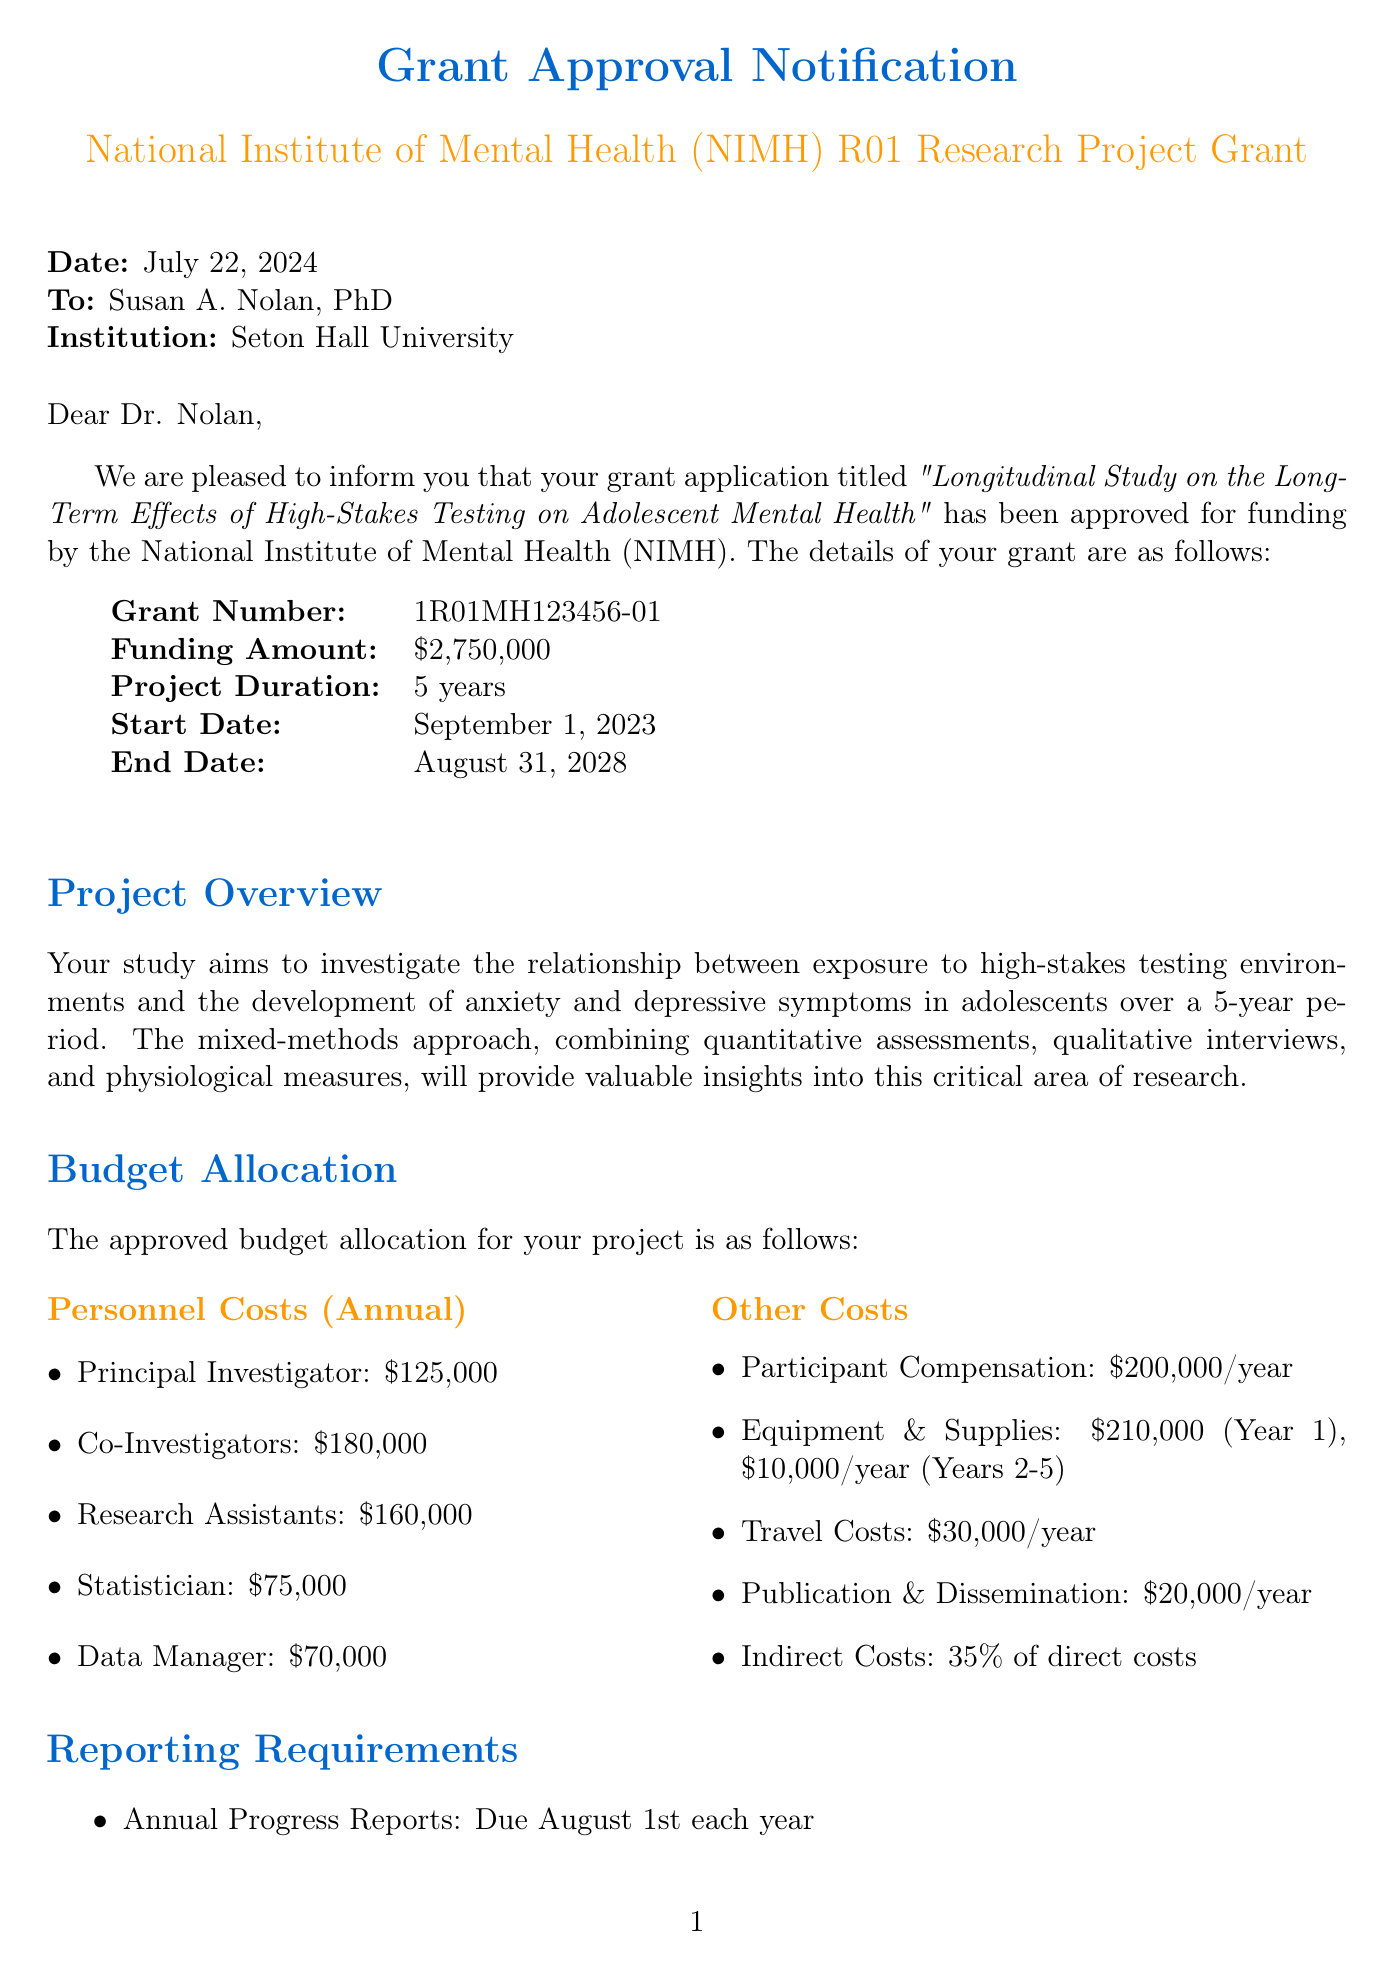What is the grant name? The grant name is specifically stated in the document.
Answer: National Institute of Mental Health (NIMH) R01 Research Project Grant What is the funding amount? The funding amount is clearly provided in the budget section of the letter.
Answer: $2,750,000 What is the project duration? The project duration is mentioned directly under the grant details.
Answer: 5 years When is the final report due? The due date for the final report is explicitly outlined in the reporting requirements.
Answer: November 30, 2028 What age group does the study target? The participant age range is specified in the study overview.
Answer: 13-18 years old What is the method of the study? The study methodology is described under the project overview section.
Answer: Mixed-methods approach combining quantitative assessments, qualitative interviews, and physiological measures What percentage of indirect costs is included in the budget? The percentage of indirect costs can be found in the budget allocation section.
Answer: 35% Who is the principal investigator? The name of the principal investigator is listed at the beginning of the document.
Answer: Susan A. Nolan, PhD Which institution collaborated on the study? Collaborating institutions are mentioned in the study overview section.
Answer: New Jersey Department of Education 